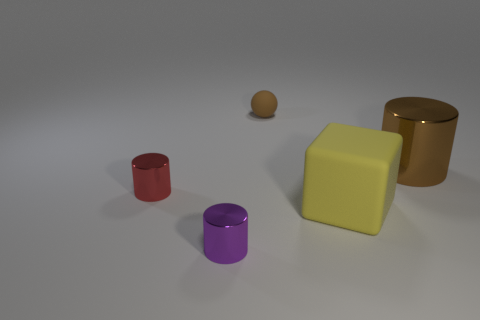Subtract all tiny shiny cylinders. How many cylinders are left? 1 Add 4 big things. How many objects exist? 9 Subtract 1 cylinders. How many cylinders are left? 2 Subtract all blue cylinders. Subtract all brown spheres. How many cylinders are left? 3 Add 3 tiny yellow cylinders. How many tiny yellow cylinders exist? 3 Subtract 0 red cubes. How many objects are left? 5 Subtract all cylinders. How many objects are left? 2 Subtract all shiny balls. Subtract all small brown matte things. How many objects are left? 4 Add 1 metal things. How many metal things are left? 4 